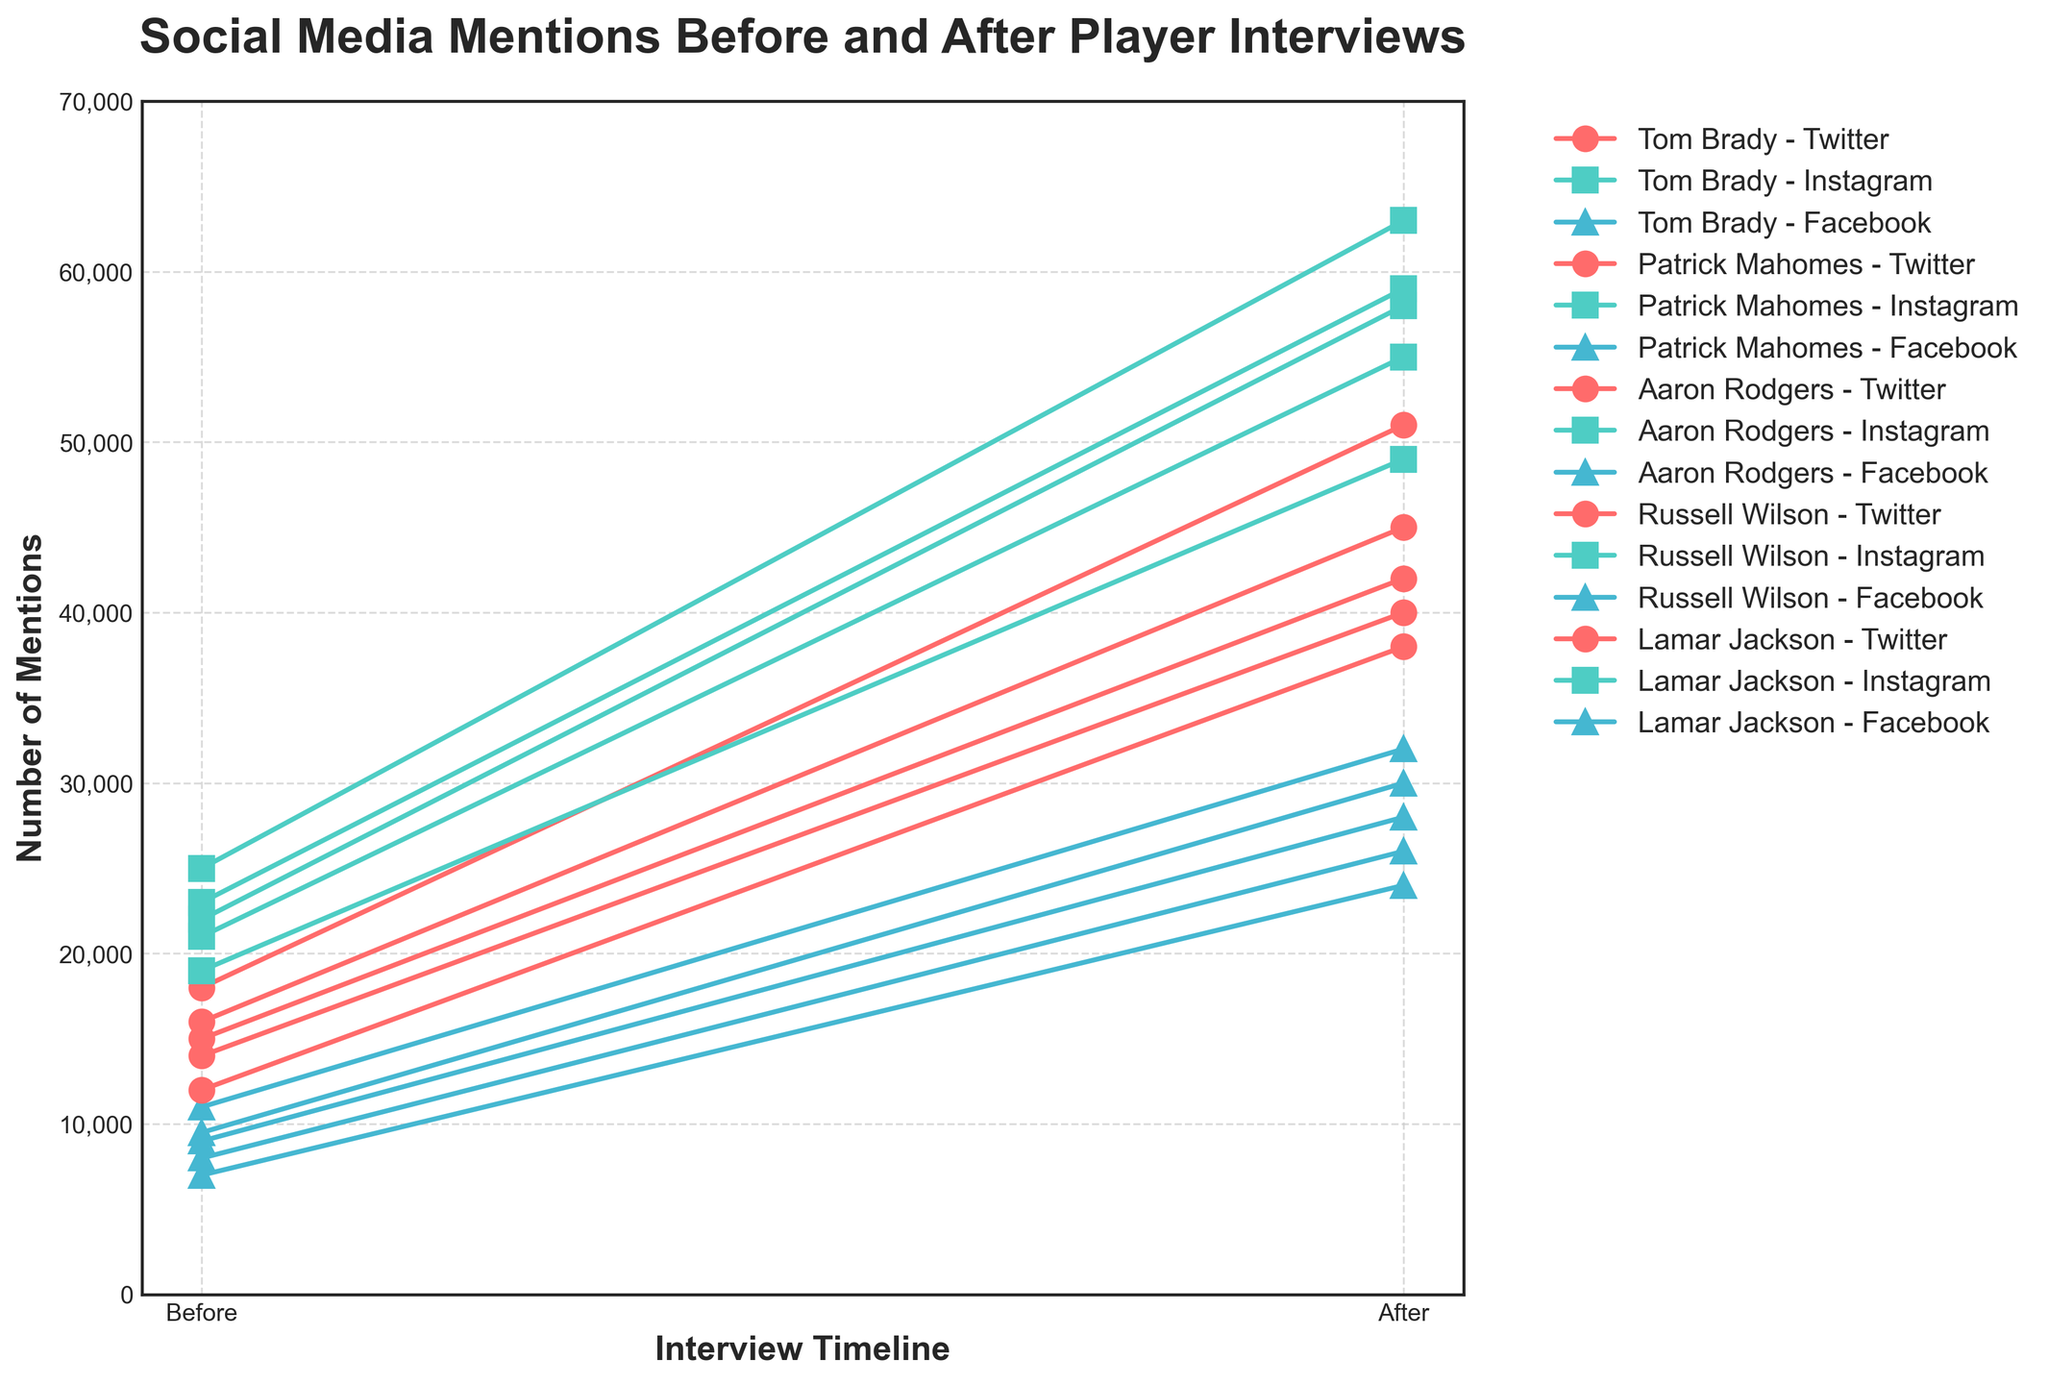What player had the highest number of mentions on Instagram before the interview? Look at the values only for Instagram in the "before interview" series and identify the highest value. Tom Brady had 22,000, Patrick Mahomes had 25,000, Aaron Rodgers had 19,000, Russell Wilson had 21,000, Lamar Jackson had 23,000. Patrick Mahomes's 25,000 is the highest.
Answer: Patrick Mahomes Which player and platform had the greatest increase in mentions after the interview? Calculate the difference between "after interview" and "before interview" for each player and each platform, and find the maximum increase. Tom Brady on Instagram: 58,000 - 22,000 = 36,000; Patrick Mahomes on Instagram: 63,000 - 25,000 = 38,000; Aaron Rodgers on Twitter: 38,000 - 12,000 = 26,000; etc. The maximum increase is 38,000 for Patrick Mahomes on Instagram.
Answer: Patrick Mahomes on Instagram What is the sum of mentions on Facebook for all players before the interviews? Sum the "before interview" values for Facebook only. Tom Brady: 9,000; Patrick Mahomes: 11,000; Aaron Rodgers: 7,000; Russell Wilson: 8,000; Lamar Jackson: 9,500. Calculate the sum: 9,000 + 11,000 + 7,000 + 8,000 + 9,500 = 44,500.
Answer: 44,500 Which player had the smallest relative increase in mentions on Twitter after the interview? Calculate the relative increase ( (after − before) / before ) for Twitter mentions for each player, and identify the smallest value. Tom Brady: (42,000 - 15,000) / 15,000 = 1.8; Patrick Mahomes: (51,000 - 18,000) / 18,000 = 1.83; Aaron Rodgers: (38,000 - 12,000) / 12,000 = 2.17; Russell Wilson: (40,000 - 14,000) / 14,000 = 1.86; Lamar Jackson: (45,000 - 16,000) / 16,000 = 1.81. The smallest increase is for Tom Brady with 1.8.
Answer: Tom Brady On which platform did Aaron Rodgers see the highest increase in mentions after the interview? Subtract "before interview" from "after interview" for each platform for Aaron Rodgers and identify the highest increase. Twitter: 38,000 - 12,000 = 26,000; Instagram: 49,000 - 19,000 = 30,000; Facebook: 24,000 - 7,000 = 17,000. The highest increase is on Instagram with 30,000.
Answer: Instagram How many times more mentions did Russell Wilson have on Instagram after the interview compared to Facebook before the interview? Divide the "after interview" value of Instagram for Russell Wilson by the "before interview" value of Facebook. Instagram: 55,000; Facebook: 8,000; 55,000 / 8,000 = 6.875.
Answer: 6.875 Which player had the highest total social media mentions across all platforms after the interview? Add the "after interview" values for all platforms for each player, and identify the highest total. Tom Brady: 42,000 + 58,000 + 28,000 = 128,000; Patrick Mahomes: 51,000 + 63,000 + 32,000 = 146,000; Aaron Rodgers: 38,000 + 49,000 + 24,000 = 111,000; Russell Wilson: 40,000 + 55,000 + 26,000 = 121,000; Lamar Jackson: 45,000 + 59,000 + 30,000 = 134,000. The highest total is for Patrick Mahomes with 146,000 mentions.
Answer: Patrick Mahomes Which player had the most uniform increase across all platforms? Calculate the increase from "before interview" to "after interview" for each platform and check the differences in growth. Tom Brady: Twitter: 42,000 - 15,000 = 27,000; Instagram: 58,000 - 22,000 = 36,000; Facebook: 28,000 - 9,000 = 19,000. Patrick Mahomes: Twitter: 51,000 - 18,000 = 33,000; Instagram: 63,000 - 25,000 = 38,000; Facebook: 32,000 - 11,000 = 21,000. Aaron Rodgers: Twitter: 38,000 - 12,000 = 26,000; Instagram: 49,000 - 19,000 = 30,000; Facebook: 24,000 - 7,000 = 17,000. Russell Wilson: Twitter: 40,000 - 14,000 = 26,000; Instagram: 55,000 - 21,000 = 34,000; Facebook: 26,000 - 8,000 = 18,000. Lamar Jackson: Twitter: 45,000 - 16,000 = 29,000; Instagram: 59,000 - 23,000 = 36,000; Facebook: 30,000 - 9,500 = 20,500. Aaron Rodgers has the most uniform increases ranging from 17,000 to 30,000.
Answer: Aaron Rodgers 